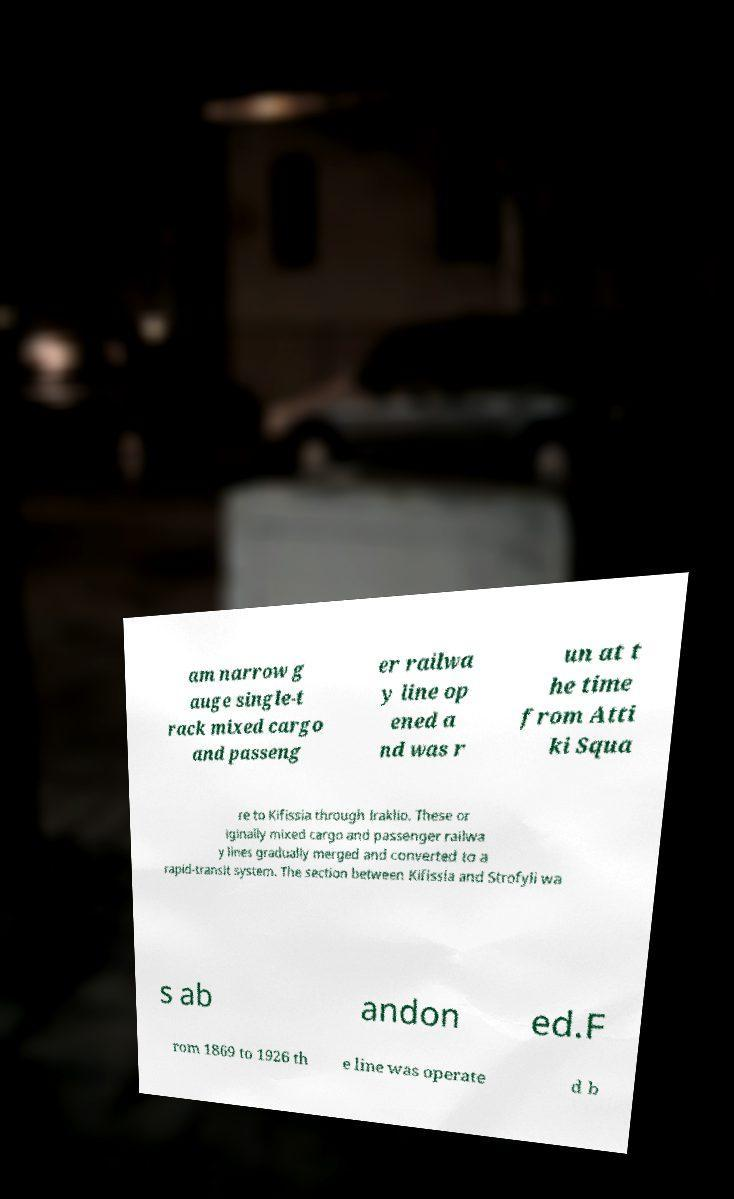Please identify and transcribe the text found in this image. am narrow g auge single-t rack mixed cargo and passeng er railwa y line op ened a nd was r un at t he time from Atti ki Squa re to Kifissia through Iraklio. These or iginally mixed cargo and passenger railwa y lines gradually merged and converted to a rapid-transit system. The section between Kifissia and Strofyli wa s ab andon ed.F rom 1869 to 1926 th e line was operate d b 